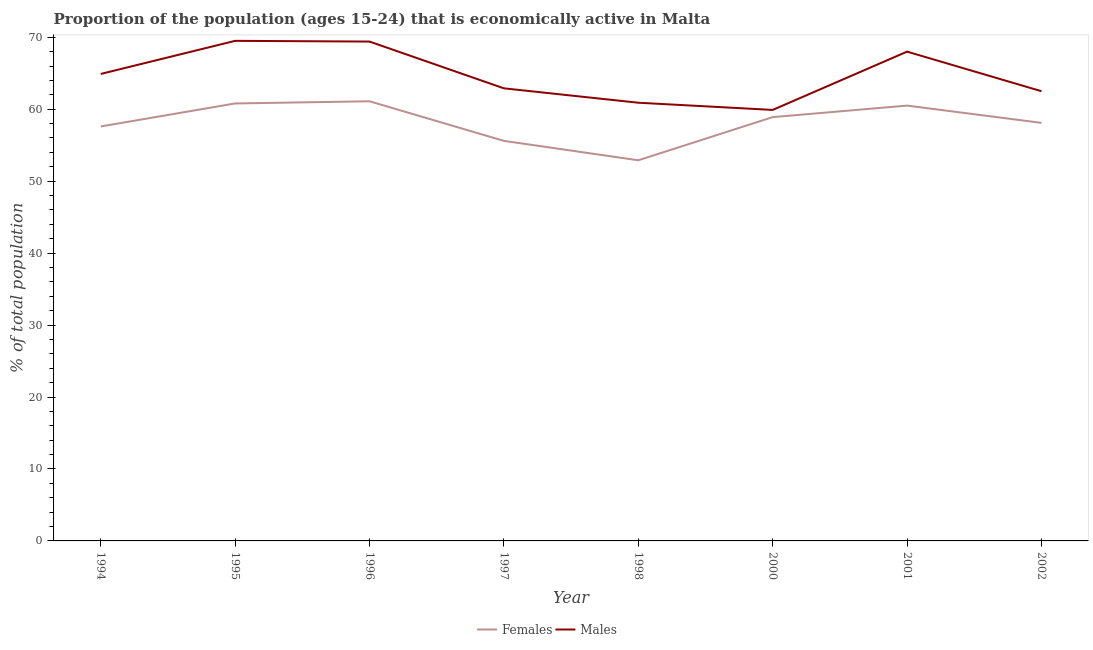Is the number of lines equal to the number of legend labels?
Make the answer very short. Yes. What is the percentage of economically active male population in 1996?
Offer a very short reply. 69.4. Across all years, what is the maximum percentage of economically active female population?
Provide a short and direct response. 61.1. Across all years, what is the minimum percentage of economically active male population?
Keep it short and to the point. 59.9. In which year was the percentage of economically active female population maximum?
Your response must be concise. 1996. In which year was the percentage of economically active male population minimum?
Provide a succinct answer. 2000. What is the total percentage of economically active male population in the graph?
Provide a short and direct response. 518. What is the difference between the percentage of economically active male population in 1995 and that in 2002?
Your answer should be compact. 7. What is the difference between the percentage of economically active male population in 1997 and the percentage of economically active female population in 1995?
Your response must be concise. 2.1. What is the average percentage of economically active male population per year?
Make the answer very short. 64.75. In how many years, is the percentage of economically active female population greater than 2 %?
Offer a very short reply. 8. What is the ratio of the percentage of economically active male population in 1994 to that in 2000?
Provide a short and direct response. 1.08. What is the difference between the highest and the second highest percentage of economically active male population?
Give a very brief answer. 0.1. What is the difference between the highest and the lowest percentage of economically active female population?
Keep it short and to the point. 8.2. Is the percentage of economically active female population strictly less than the percentage of economically active male population over the years?
Give a very brief answer. Yes. How many years are there in the graph?
Offer a terse response. 8. What is the difference between two consecutive major ticks on the Y-axis?
Keep it short and to the point. 10. Does the graph contain any zero values?
Your answer should be very brief. No. Does the graph contain grids?
Offer a very short reply. No. What is the title of the graph?
Keep it short and to the point. Proportion of the population (ages 15-24) that is economically active in Malta. Does "Constant 2005 US$" appear as one of the legend labels in the graph?
Ensure brevity in your answer.  No. What is the label or title of the X-axis?
Make the answer very short. Year. What is the label or title of the Y-axis?
Give a very brief answer. % of total population. What is the % of total population in Females in 1994?
Provide a succinct answer. 57.6. What is the % of total population of Males in 1994?
Give a very brief answer. 64.9. What is the % of total population of Females in 1995?
Your answer should be compact. 60.8. What is the % of total population of Males in 1995?
Provide a succinct answer. 69.5. What is the % of total population of Females in 1996?
Give a very brief answer. 61.1. What is the % of total population in Males in 1996?
Your answer should be compact. 69.4. What is the % of total population in Females in 1997?
Provide a short and direct response. 55.6. What is the % of total population in Males in 1997?
Your answer should be very brief. 62.9. What is the % of total population in Females in 1998?
Provide a short and direct response. 52.9. What is the % of total population in Males in 1998?
Give a very brief answer. 60.9. What is the % of total population in Females in 2000?
Give a very brief answer. 58.9. What is the % of total population in Males in 2000?
Give a very brief answer. 59.9. What is the % of total population of Females in 2001?
Your answer should be compact. 60.5. What is the % of total population of Females in 2002?
Give a very brief answer. 58.1. What is the % of total population of Males in 2002?
Make the answer very short. 62.5. Across all years, what is the maximum % of total population of Females?
Give a very brief answer. 61.1. Across all years, what is the maximum % of total population in Males?
Offer a very short reply. 69.5. Across all years, what is the minimum % of total population of Females?
Offer a very short reply. 52.9. Across all years, what is the minimum % of total population of Males?
Offer a very short reply. 59.9. What is the total % of total population of Females in the graph?
Ensure brevity in your answer.  465.5. What is the total % of total population of Males in the graph?
Give a very brief answer. 518. What is the difference between the % of total population of Females in 1994 and that in 1995?
Offer a very short reply. -3.2. What is the difference between the % of total population of Males in 1994 and that in 1995?
Provide a succinct answer. -4.6. What is the difference between the % of total population of Females in 1994 and that in 1996?
Ensure brevity in your answer.  -3.5. What is the difference between the % of total population in Females in 1994 and that in 1997?
Provide a succinct answer. 2. What is the difference between the % of total population of Males in 1994 and that in 1998?
Offer a terse response. 4. What is the difference between the % of total population of Females in 1994 and that in 2000?
Offer a terse response. -1.3. What is the difference between the % of total population in Females in 1994 and that in 2001?
Provide a succinct answer. -2.9. What is the difference between the % of total population of Males in 1994 and that in 2001?
Your answer should be compact. -3.1. What is the difference between the % of total population in Females in 1994 and that in 2002?
Your answer should be very brief. -0.5. What is the difference between the % of total population of Males in 1994 and that in 2002?
Give a very brief answer. 2.4. What is the difference between the % of total population in Females in 1995 and that in 1996?
Provide a succinct answer. -0.3. What is the difference between the % of total population of Females in 1995 and that in 1998?
Provide a short and direct response. 7.9. What is the difference between the % of total population in Males in 1995 and that in 1998?
Provide a succinct answer. 8.6. What is the difference between the % of total population in Females in 1995 and that in 2000?
Keep it short and to the point. 1.9. What is the difference between the % of total population in Males in 1995 and that in 2000?
Offer a terse response. 9.6. What is the difference between the % of total population of Males in 1995 and that in 2002?
Offer a terse response. 7. What is the difference between the % of total population in Females in 1996 and that in 1997?
Your answer should be very brief. 5.5. What is the difference between the % of total population in Males in 1996 and that in 1997?
Offer a very short reply. 6.5. What is the difference between the % of total population in Females in 1996 and that in 1998?
Your answer should be compact. 8.2. What is the difference between the % of total population of Males in 1996 and that in 1998?
Provide a short and direct response. 8.5. What is the difference between the % of total population in Females in 1996 and that in 2000?
Your answer should be compact. 2.2. What is the difference between the % of total population in Males in 1996 and that in 2001?
Your answer should be compact. 1.4. What is the difference between the % of total population of Females in 1996 and that in 2002?
Ensure brevity in your answer.  3. What is the difference between the % of total population in Males in 1996 and that in 2002?
Keep it short and to the point. 6.9. What is the difference between the % of total population of Males in 1997 and that in 2000?
Offer a terse response. 3. What is the difference between the % of total population of Females in 1997 and that in 2001?
Provide a short and direct response. -4.9. What is the difference between the % of total population in Males in 1997 and that in 2001?
Offer a very short reply. -5.1. What is the difference between the % of total population in Females in 1997 and that in 2002?
Give a very brief answer. -2.5. What is the difference between the % of total population in Females in 1998 and that in 2000?
Ensure brevity in your answer.  -6. What is the difference between the % of total population in Males in 1998 and that in 2000?
Give a very brief answer. 1. What is the difference between the % of total population in Males in 2000 and that in 2002?
Give a very brief answer. -2.6. What is the difference between the % of total population of Females in 2001 and that in 2002?
Give a very brief answer. 2.4. What is the difference between the % of total population of Males in 2001 and that in 2002?
Make the answer very short. 5.5. What is the difference between the % of total population of Females in 1994 and the % of total population of Males in 1995?
Your answer should be very brief. -11.9. What is the difference between the % of total population in Females in 1994 and the % of total population in Males in 1996?
Offer a very short reply. -11.8. What is the difference between the % of total population in Females in 1994 and the % of total population in Males in 1997?
Offer a terse response. -5.3. What is the difference between the % of total population in Females in 1994 and the % of total population in Males in 1998?
Make the answer very short. -3.3. What is the difference between the % of total population in Females in 1994 and the % of total population in Males in 2001?
Ensure brevity in your answer.  -10.4. What is the difference between the % of total population of Females in 1996 and the % of total population of Males in 1997?
Your answer should be very brief. -1.8. What is the difference between the % of total population in Females in 1996 and the % of total population in Males in 1998?
Offer a very short reply. 0.2. What is the difference between the % of total population of Females in 1996 and the % of total population of Males in 2000?
Your response must be concise. 1.2. What is the difference between the % of total population in Females in 1996 and the % of total population in Males in 2002?
Provide a succinct answer. -1.4. What is the difference between the % of total population of Females in 1997 and the % of total population of Males in 2001?
Provide a succinct answer. -12.4. What is the difference between the % of total population of Females in 1997 and the % of total population of Males in 2002?
Your response must be concise. -6.9. What is the difference between the % of total population of Females in 1998 and the % of total population of Males in 2000?
Make the answer very short. -7. What is the difference between the % of total population of Females in 1998 and the % of total population of Males in 2001?
Your response must be concise. -15.1. What is the difference between the % of total population of Females in 2000 and the % of total population of Males in 2001?
Ensure brevity in your answer.  -9.1. What is the difference between the % of total population of Females in 2000 and the % of total population of Males in 2002?
Ensure brevity in your answer.  -3.6. What is the difference between the % of total population in Females in 2001 and the % of total population in Males in 2002?
Give a very brief answer. -2. What is the average % of total population in Females per year?
Your answer should be very brief. 58.19. What is the average % of total population of Males per year?
Give a very brief answer. 64.75. In the year 1995, what is the difference between the % of total population of Females and % of total population of Males?
Your response must be concise. -8.7. In the year 1998, what is the difference between the % of total population of Females and % of total population of Males?
Offer a very short reply. -8. In the year 2001, what is the difference between the % of total population in Females and % of total population in Males?
Offer a terse response. -7.5. What is the ratio of the % of total population in Females in 1994 to that in 1995?
Offer a very short reply. 0.95. What is the ratio of the % of total population in Males in 1994 to that in 1995?
Provide a succinct answer. 0.93. What is the ratio of the % of total population in Females in 1994 to that in 1996?
Your response must be concise. 0.94. What is the ratio of the % of total population in Males in 1994 to that in 1996?
Provide a succinct answer. 0.94. What is the ratio of the % of total population in Females in 1994 to that in 1997?
Offer a terse response. 1.04. What is the ratio of the % of total population in Males in 1994 to that in 1997?
Provide a succinct answer. 1.03. What is the ratio of the % of total population in Females in 1994 to that in 1998?
Provide a short and direct response. 1.09. What is the ratio of the % of total population in Males in 1994 to that in 1998?
Offer a terse response. 1.07. What is the ratio of the % of total population in Females in 1994 to that in 2000?
Keep it short and to the point. 0.98. What is the ratio of the % of total population in Males in 1994 to that in 2000?
Make the answer very short. 1.08. What is the ratio of the % of total population in Females in 1994 to that in 2001?
Your answer should be very brief. 0.95. What is the ratio of the % of total population in Males in 1994 to that in 2001?
Provide a succinct answer. 0.95. What is the ratio of the % of total population in Males in 1994 to that in 2002?
Give a very brief answer. 1.04. What is the ratio of the % of total population in Females in 1995 to that in 1996?
Ensure brevity in your answer.  1. What is the ratio of the % of total population of Males in 1995 to that in 1996?
Offer a terse response. 1. What is the ratio of the % of total population of Females in 1995 to that in 1997?
Keep it short and to the point. 1.09. What is the ratio of the % of total population in Males in 1995 to that in 1997?
Ensure brevity in your answer.  1.1. What is the ratio of the % of total population of Females in 1995 to that in 1998?
Make the answer very short. 1.15. What is the ratio of the % of total population in Males in 1995 to that in 1998?
Offer a very short reply. 1.14. What is the ratio of the % of total population in Females in 1995 to that in 2000?
Keep it short and to the point. 1.03. What is the ratio of the % of total population of Males in 1995 to that in 2000?
Offer a very short reply. 1.16. What is the ratio of the % of total population of Males in 1995 to that in 2001?
Give a very brief answer. 1.02. What is the ratio of the % of total population of Females in 1995 to that in 2002?
Your answer should be compact. 1.05. What is the ratio of the % of total population of Males in 1995 to that in 2002?
Make the answer very short. 1.11. What is the ratio of the % of total population in Females in 1996 to that in 1997?
Give a very brief answer. 1.1. What is the ratio of the % of total population in Males in 1996 to that in 1997?
Your answer should be very brief. 1.1. What is the ratio of the % of total population of Females in 1996 to that in 1998?
Offer a very short reply. 1.16. What is the ratio of the % of total population in Males in 1996 to that in 1998?
Keep it short and to the point. 1.14. What is the ratio of the % of total population of Females in 1996 to that in 2000?
Keep it short and to the point. 1.04. What is the ratio of the % of total population of Males in 1996 to that in 2000?
Make the answer very short. 1.16. What is the ratio of the % of total population of Females in 1996 to that in 2001?
Your answer should be compact. 1.01. What is the ratio of the % of total population in Males in 1996 to that in 2001?
Your answer should be compact. 1.02. What is the ratio of the % of total population in Females in 1996 to that in 2002?
Keep it short and to the point. 1.05. What is the ratio of the % of total population in Males in 1996 to that in 2002?
Your answer should be compact. 1.11. What is the ratio of the % of total population of Females in 1997 to that in 1998?
Provide a succinct answer. 1.05. What is the ratio of the % of total population of Males in 1997 to that in 1998?
Offer a terse response. 1.03. What is the ratio of the % of total population of Females in 1997 to that in 2000?
Offer a very short reply. 0.94. What is the ratio of the % of total population of Males in 1997 to that in 2000?
Ensure brevity in your answer.  1.05. What is the ratio of the % of total population in Females in 1997 to that in 2001?
Make the answer very short. 0.92. What is the ratio of the % of total population of Males in 1997 to that in 2001?
Offer a very short reply. 0.93. What is the ratio of the % of total population of Males in 1997 to that in 2002?
Give a very brief answer. 1.01. What is the ratio of the % of total population of Females in 1998 to that in 2000?
Offer a very short reply. 0.9. What is the ratio of the % of total population in Males in 1998 to that in 2000?
Give a very brief answer. 1.02. What is the ratio of the % of total population of Females in 1998 to that in 2001?
Provide a short and direct response. 0.87. What is the ratio of the % of total population in Males in 1998 to that in 2001?
Give a very brief answer. 0.9. What is the ratio of the % of total population in Females in 1998 to that in 2002?
Provide a succinct answer. 0.91. What is the ratio of the % of total population in Males in 1998 to that in 2002?
Ensure brevity in your answer.  0.97. What is the ratio of the % of total population of Females in 2000 to that in 2001?
Provide a succinct answer. 0.97. What is the ratio of the % of total population in Males in 2000 to that in 2001?
Offer a very short reply. 0.88. What is the ratio of the % of total population of Females in 2000 to that in 2002?
Ensure brevity in your answer.  1.01. What is the ratio of the % of total population of Males in 2000 to that in 2002?
Ensure brevity in your answer.  0.96. What is the ratio of the % of total population of Females in 2001 to that in 2002?
Your answer should be very brief. 1.04. What is the ratio of the % of total population in Males in 2001 to that in 2002?
Provide a succinct answer. 1.09. What is the difference between the highest and the lowest % of total population of Females?
Give a very brief answer. 8.2. 